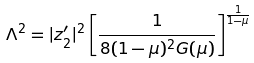<formula> <loc_0><loc_0><loc_500><loc_500>\Lambda ^ { 2 } = | z ^ { \prime } _ { 2 } | ^ { 2 } \left [ \frac { 1 } { 8 ( 1 - \mu ) ^ { 2 } G ( \mu ) } \right ] ^ { \frac { 1 } { 1 - \mu } }</formula> 